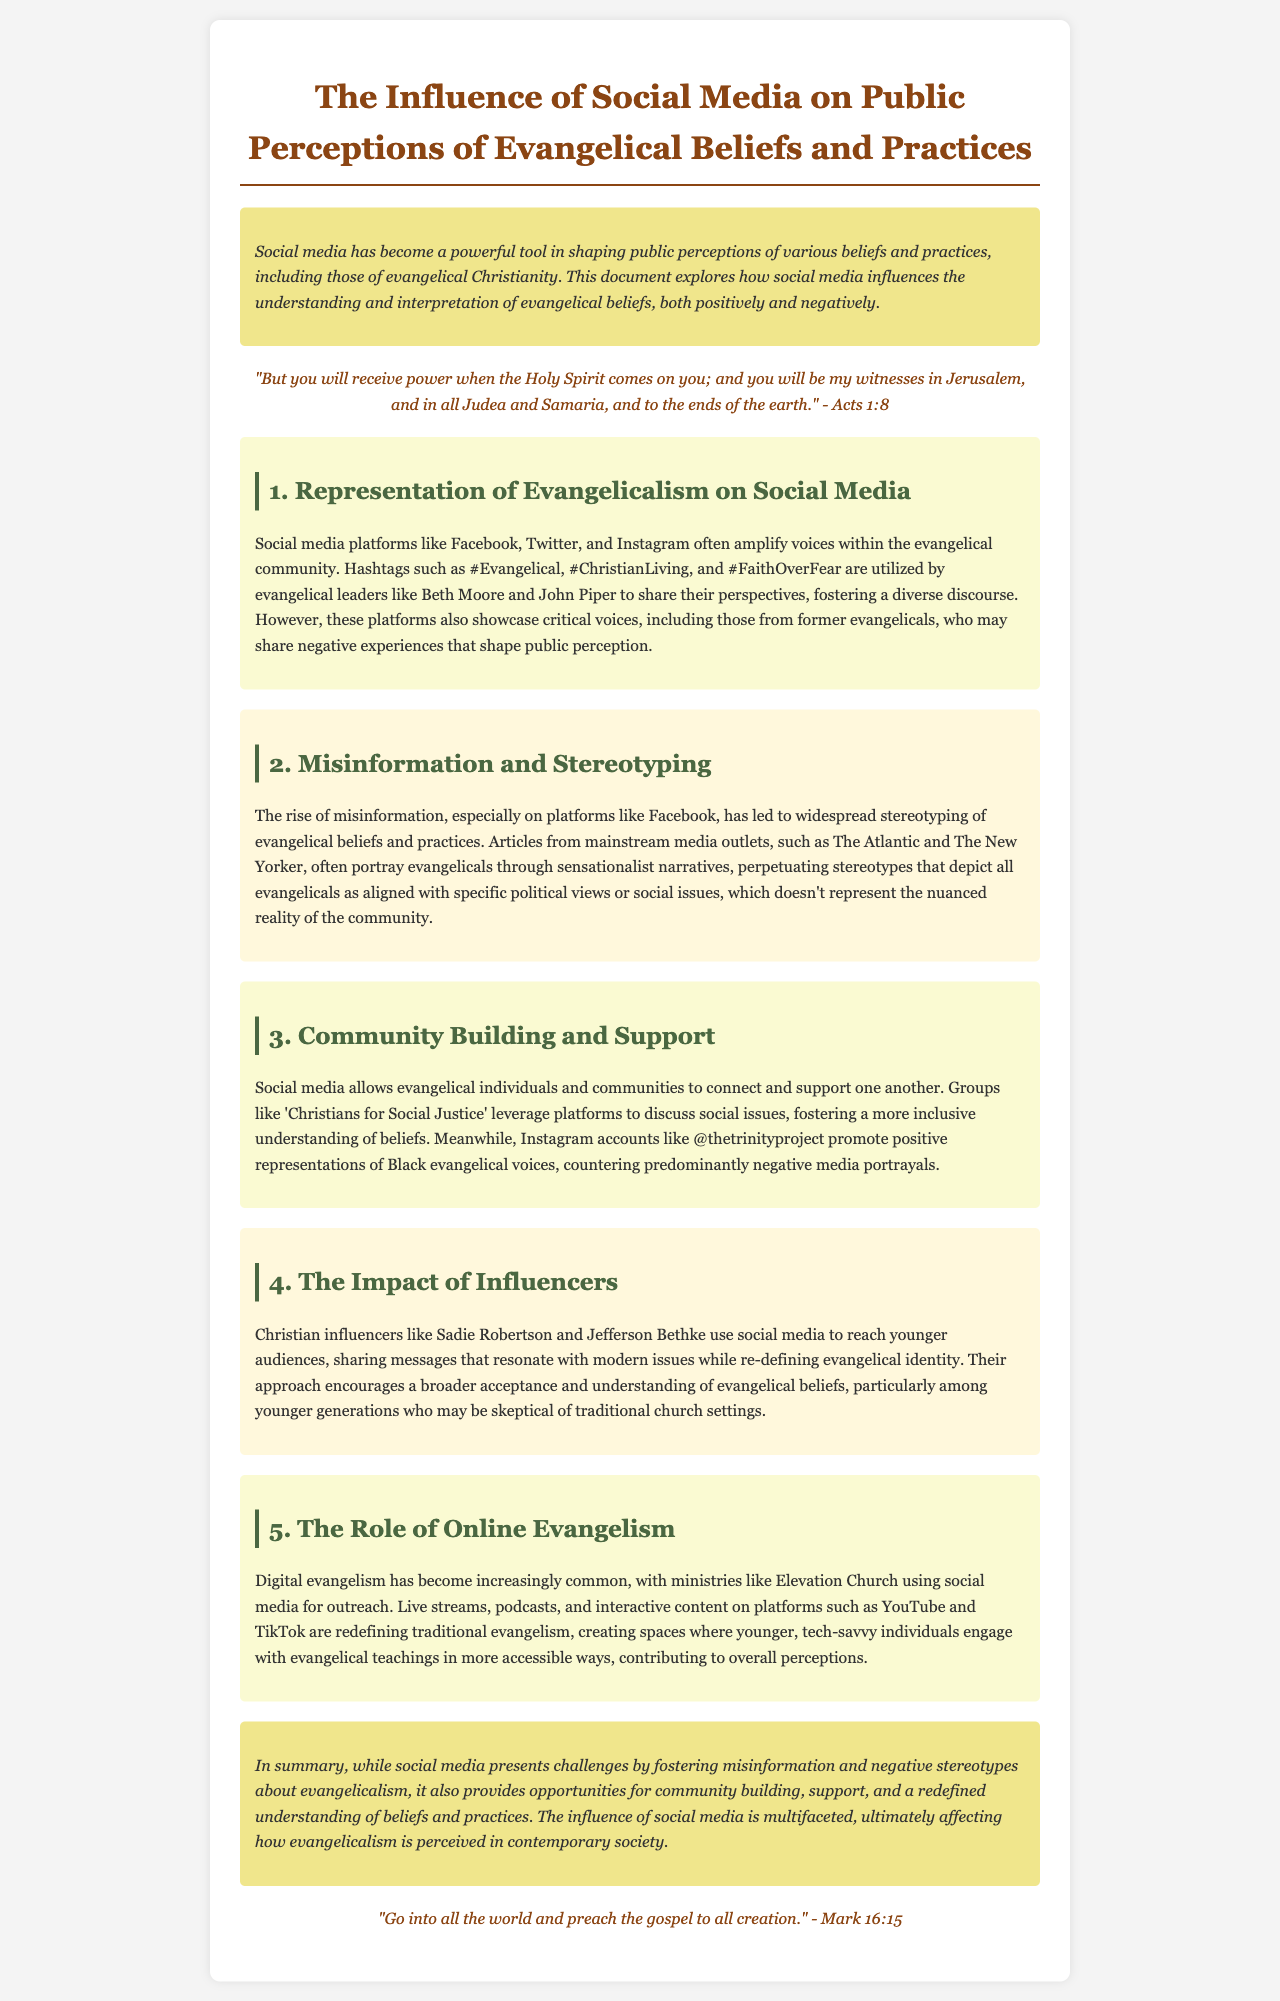What is the title of the report? The title of the report is stated at the top of the document, summarizing its main focus.
Answer: The Influence of Social Media on Public Perceptions of Evangelical Beliefs and Practices How many sections are there in the document? The number of sections can be counted in the body of the report, excluding the introduction and conclusion.
Answer: Five Who are two evangelical leaders mentioned in the report? The report lists specific evangelical leaders that engage with social media in the representation section.
Answer: Beth Moore and John Piper What type of content is frequently shared by Christian influencers? The document describes the type of messaging shared by influencers to connect with younger audiences.
Answer: Messages that resonate with modern issues Which social media platform is specifically mentioned for digital evangelism? The document cites a particular platform where digital evangelism activities take place.
Answer: TikTok What is a common negative portrayal of evangelicals noted in the document? The report discusses how media outlets portray evangelicals in a particular way that is misleading.
Answer: Sensationalist narratives What is the primary purpose of social media for evangelical communities? The report describes how social media functions as a tool for connection among the evangelical community.
Answer: Community building and support Which verse is quoted at the end of the document? The document includes a concluding bible verse that emphasizes spreading the gospel.
Answer: "Go into all the world and preach the gospel to all creation." - Mark 16:15 